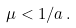Convert formula to latex. <formula><loc_0><loc_0><loc_500><loc_500>\mu < 1 / a \, .</formula> 